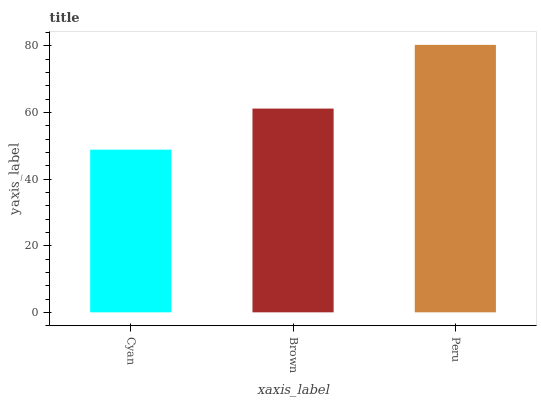Is Brown the minimum?
Answer yes or no. No. Is Brown the maximum?
Answer yes or no. No. Is Brown greater than Cyan?
Answer yes or no. Yes. Is Cyan less than Brown?
Answer yes or no. Yes. Is Cyan greater than Brown?
Answer yes or no. No. Is Brown less than Cyan?
Answer yes or no. No. Is Brown the high median?
Answer yes or no. Yes. Is Brown the low median?
Answer yes or no. Yes. Is Peru the high median?
Answer yes or no. No. Is Cyan the low median?
Answer yes or no. No. 